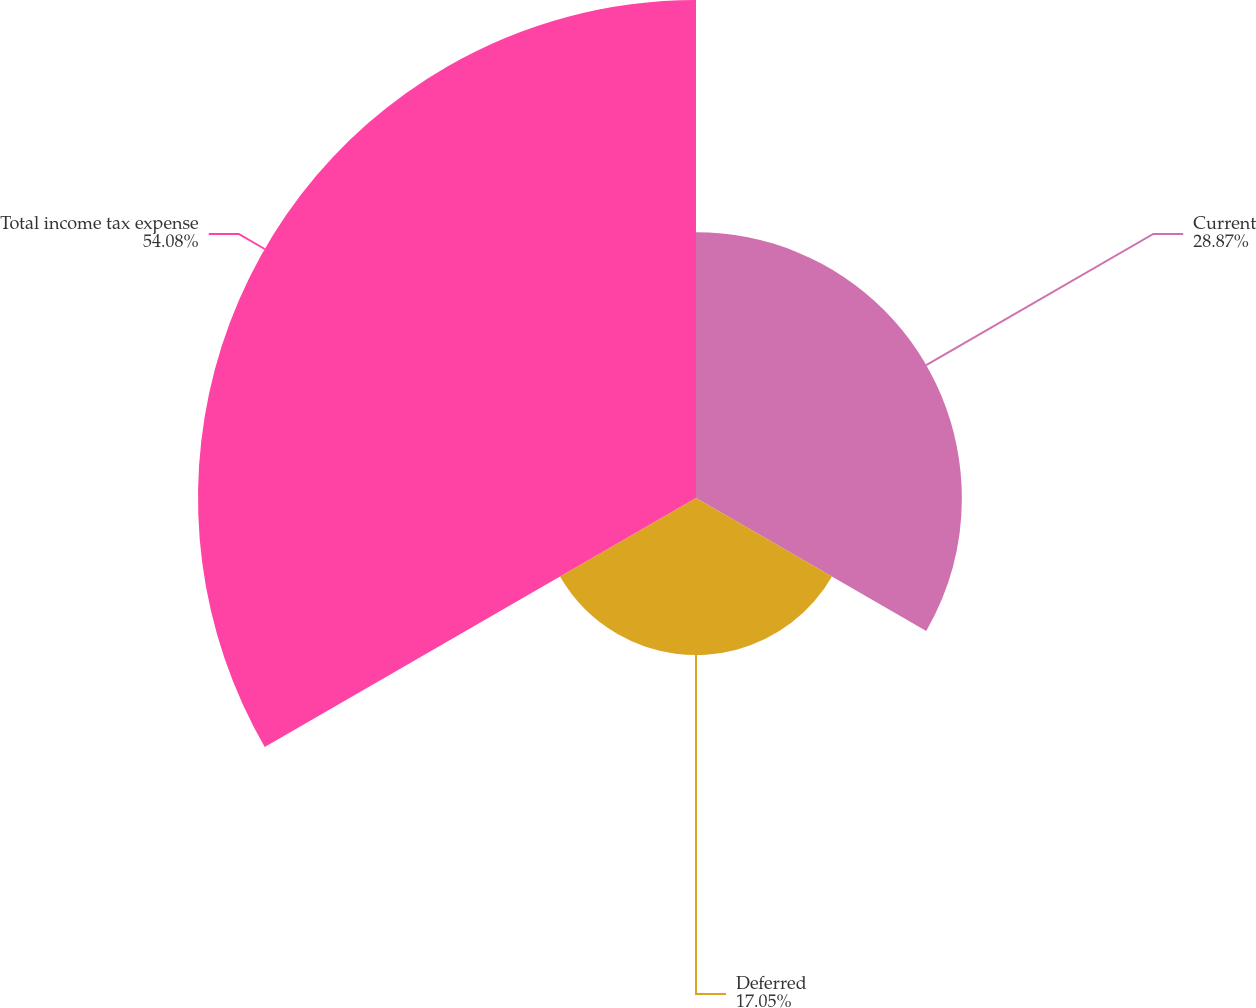<chart> <loc_0><loc_0><loc_500><loc_500><pie_chart><fcel>Current<fcel>Deferred<fcel>Total income tax expense<nl><fcel>28.87%<fcel>17.05%<fcel>54.08%<nl></chart> 